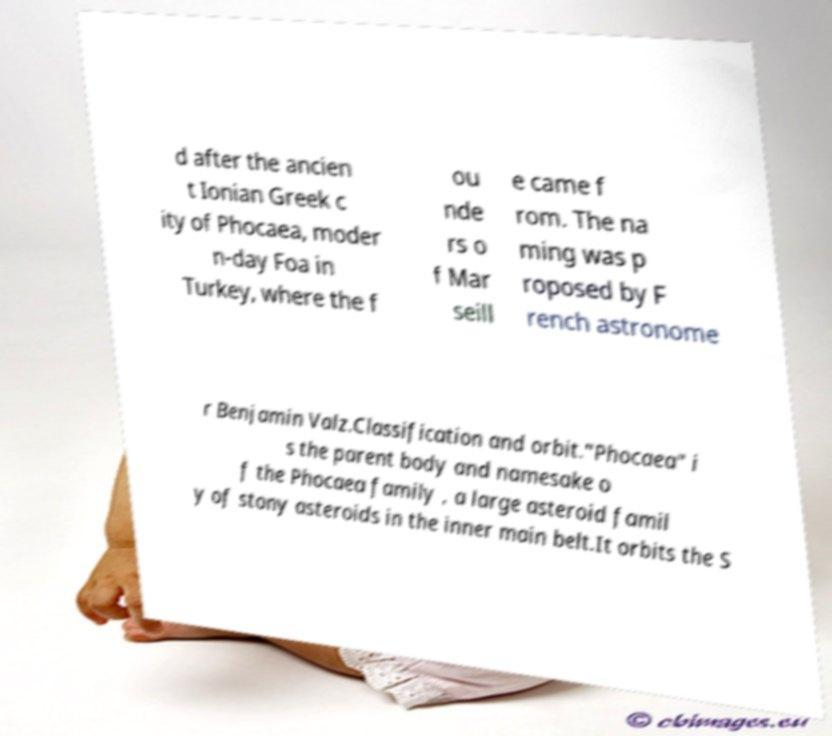What messages or text are displayed in this image? I need them in a readable, typed format. d after the ancien t Ionian Greek c ity of Phocaea, moder n-day Foa in Turkey, where the f ou nde rs o f Mar seill e came f rom. The na ming was p roposed by F rench astronome r Benjamin Valz.Classification and orbit."Phocaea" i s the parent body and namesake o f the Phocaea family , a large asteroid famil y of stony asteroids in the inner main belt.It orbits the S 